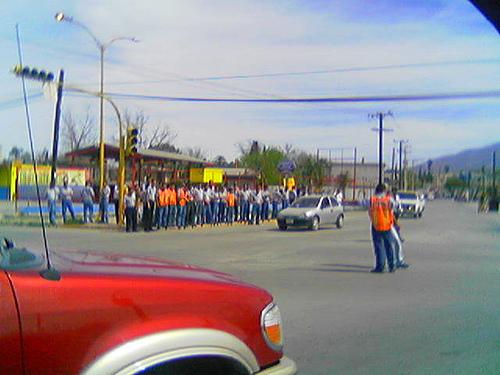Why are these people lined up at the intersection?
Give a very brief answer. Strike. Is anyone wearing orange vests?
Give a very brief answer. Yes. What color is the car I?
Short answer required. Red. 